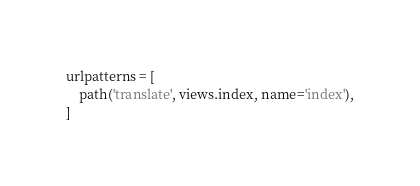Convert code to text. <code><loc_0><loc_0><loc_500><loc_500><_Python_>urlpatterns = [   
    path('translate', views.index, name='index'),
]
</code> 